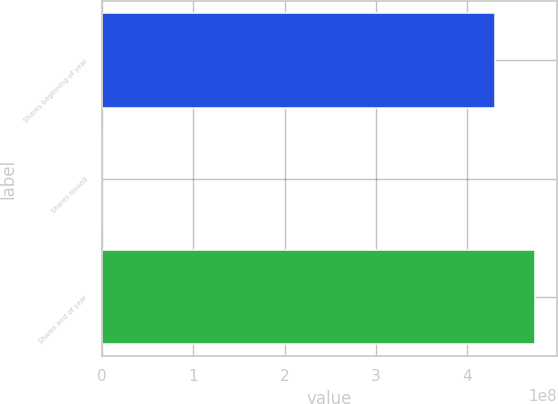Convert chart. <chart><loc_0><loc_0><loc_500><loc_500><bar_chart><fcel>Shares beginning of year<fcel>Shares issued<fcel>Shares end of year<nl><fcel>4.3029e+08<fcel>24778<fcel>4.74546e+08<nl></chart> 